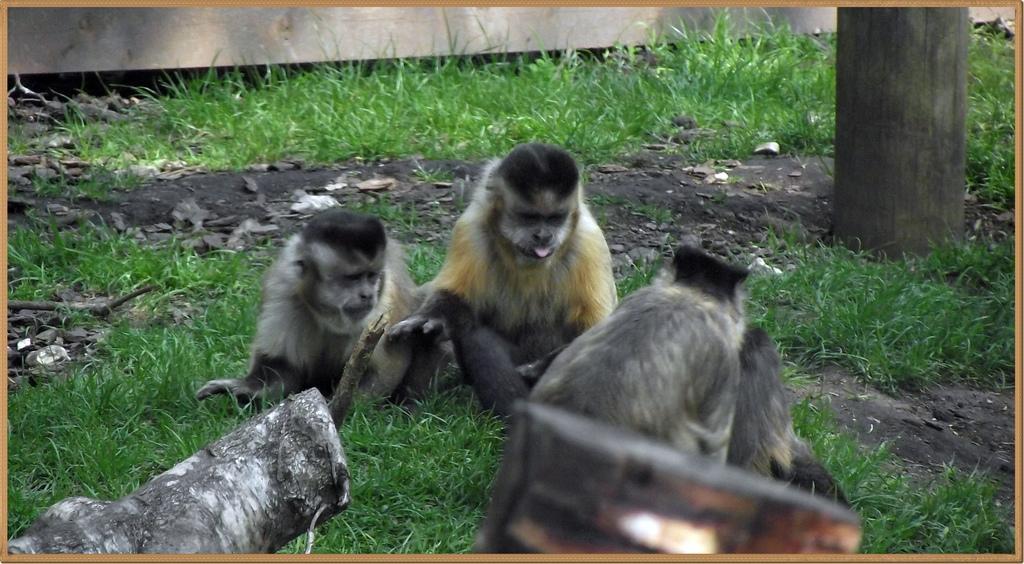In one or two sentences, can you explain what this image depicts? In this picture we can see animals, grass, wooden objects, leaves and tree trunk. 